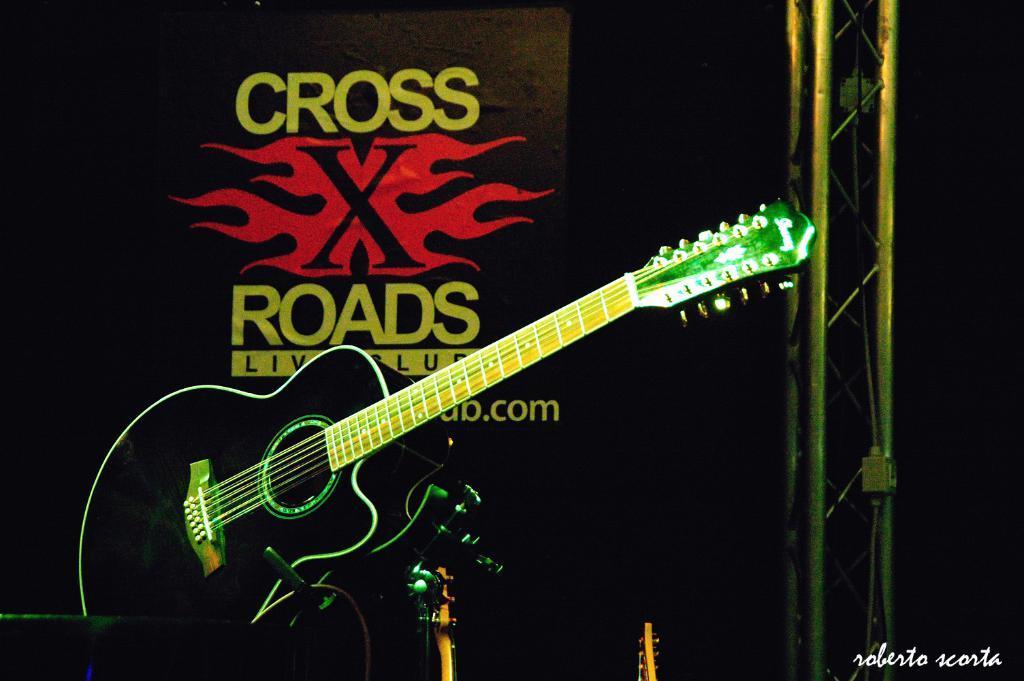Can you describe this image briefly? In the image there is a guitar in the foreground, behind the guitar on the right side there is some object and in the background there is a logo with some names. 